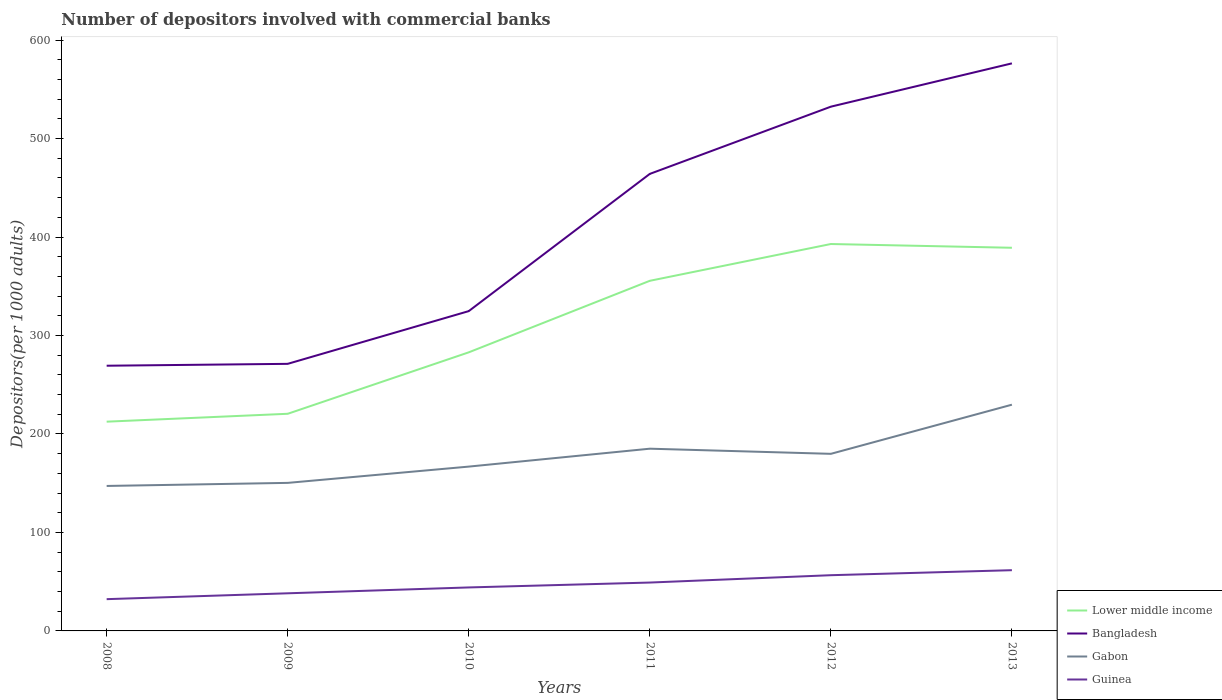Does the line corresponding to Gabon intersect with the line corresponding to Lower middle income?
Keep it short and to the point. No. Across all years, what is the maximum number of depositors involved with commercial banks in Gabon?
Your answer should be compact. 147.22. What is the total number of depositors involved with commercial banks in Gabon in the graph?
Your response must be concise. -79.41. What is the difference between the highest and the second highest number of depositors involved with commercial banks in Gabon?
Your answer should be very brief. 82.52. How many lines are there?
Ensure brevity in your answer.  4. What is the difference between two consecutive major ticks on the Y-axis?
Your answer should be compact. 100. Are the values on the major ticks of Y-axis written in scientific E-notation?
Offer a terse response. No. Does the graph contain any zero values?
Your answer should be compact. No. Does the graph contain grids?
Provide a short and direct response. No. Where does the legend appear in the graph?
Ensure brevity in your answer.  Bottom right. How are the legend labels stacked?
Offer a terse response. Vertical. What is the title of the graph?
Your response must be concise. Number of depositors involved with commercial banks. What is the label or title of the X-axis?
Your answer should be compact. Years. What is the label or title of the Y-axis?
Offer a very short reply. Depositors(per 1000 adults). What is the Depositors(per 1000 adults) in Lower middle income in 2008?
Offer a very short reply. 212.5. What is the Depositors(per 1000 adults) of Bangladesh in 2008?
Provide a short and direct response. 269.32. What is the Depositors(per 1000 adults) in Gabon in 2008?
Give a very brief answer. 147.22. What is the Depositors(per 1000 adults) of Guinea in 2008?
Provide a short and direct response. 32.26. What is the Depositors(per 1000 adults) in Lower middle income in 2009?
Give a very brief answer. 220.51. What is the Depositors(per 1000 adults) in Bangladesh in 2009?
Your answer should be very brief. 271.23. What is the Depositors(per 1000 adults) in Gabon in 2009?
Provide a succinct answer. 150.34. What is the Depositors(per 1000 adults) in Guinea in 2009?
Your response must be concise. 38.21. What is the Depositors(per 1000 adults) in Lower middle income in 2010?
Provide a short and direct response. 282.91. What is the Depositors(per 1000 adults) in Bangladesh in 2010?
Offer a terse response. 324.78. What is the Depositors(per 1000 adults) of Gabon in 2010?
Provide a succinct answer. 166.87. What is the Depositors(per 1000 adults) of Guinea in 2010?
Give a very brief answer. 44.16. What is the Depositors(per 1000 adults) of Lower middle income in 2011?
Keep it short and to the point. 355.56. What is the Depositors(per 1000 adults) of Bangladesh in 2011?
Offer a very short reply. 464.13. What is the Depositors(per 1000 adults) of Gabon in 2011?
Ensure brevity in your answer.  185.06. What is the Depositors(per 1000 adults) of Guinea in 2011?
Your response must be concise. 49.12. What is the Depositors(per 1000 adults) of Lower middle income in 2012?
Provide a succinct answer. 392.92. What is the Depositors(per 1000 adults) of Bangladesh in 2012?
Offer a very short reply. 532.4. What is the Depositors(per 1000 adults) in Gabon in 2012?
Ensure brevity in your answer.  179.84. What is the Depositors(per 1000 adults) in Guinea in 2012?
Give a very brief answer. 56.59. What is the Depositors(per 1000 adults) in Lower middle income in 2013?
Offer a terse response. 389.11. What is the Depositors(per 1000 adults) of Bangladesh in 2013?
Your answer should be compact. 576.37. What is the Depositors(per 1000 adults) in Gabon in 2013?
Your answer should be very brief. 229.74. What is the Depositors(per 1000 adults) of Guinea in 2013?
Keep it short and to the point. 61.68. Across all years, what is the maximum Depositors(per 1000 adults) in Lower middle income?
Offer a terse response. 392.92. Across all years, what is the maximum Depositors(per 1000 adults) in Bangladesh?
Your answer should be very brief. 576.37. Across all years, what is the maximum Depositors(per 1000 adults) of Gabon?
Provide a short and direct response. 229.74. Across all years, what is the maximum Depositors(per 1000 adults) of Guinea?
Your answer should be compact. 61.68. Across all years, what is the minimum Depositors(per 1000 adults) in Lower middle income?
Your answer should be very brief. 212.5. Across all years, what is the minimum Depositors(per 1000 adults) of Bangladesh?
Keep it short and to the point. 269.32. Across all years, what is the minimum Depositors(per 1000 adults) in Gabon?
Your answer should be very brief. 147.22. Across all years, what is the minimum Depositors(per 1000 adults) in Guinea?
Offer a terse response. 32.26. What is the total Depositors(per 1000 adults) in Lower middle income in the graph?
Ensure brevity in your answer.  1853.51. What is the total Depositors(per 1000 adults) of Bangladesh in the graph?
Your answer should be compact. 2438.22. What is the total Depositors(per 1000 adults) of Gabon in the graph?
Your response must be concise. 1059.08. What is the total Depositors(per 1000 adults) in Guinea in the graph?
Keep it short and to the point. 282.02. What is the difference between the Depositors(per 1000 adults) in Lower middle income in 2008 and that in 2009?
Keep it short and to the point. -8.01. What is the difference between the Depositors(per 1000 adults) in Bangladesh in 2008 and that in 2009?
Make the answer very short. -1.91. What is the difference between the Depositors(per 1000 adults) in Gabon in 2008 and that in 2009?
Ensure brevity in your answer.  -3.11. What is the difference between the Depositors(per 1000 adults) of Guinea in 2008 and that in 2009?
Your answer should be compact. -5.95. What is the difference between the Depositors(per 1000 adults) in Lower middle income in 2008 and that in 2010?
Provide a succinct answer. -70.41. What is the difference between the Depositors(per 1000 adults) of Bangladesh in 2008 and that in 2010?
Make the answer very short. -55.46. What is the difference between the Depositors(per 1000 adults) in Gabon in 2008 and that in 2010?
Ensure brevity in your answer.  -19.65. What is the difference between the Depositors(per 1000 adults) of Guinea in 2008 and that in 2010?
Offer a very short reply. -11.9. What is the difference between the Depositors(per 1000 adults) in Lower middle income in 2008 and that in 2011?
Make the answer very short. -143.06. What is the difference between the Depositors(per 1000 adults) in Bangladesh in 2008 and that in 2011?
Your answer should be very brief. -194.81. What is the difference between the Depositors(per 1000 adults) in Gabon in 2008 and that in 2011?
Your answer should be very brief. -37.83. What is the difference between the Depositors(per 1000 adults) in Guinea in 2008 and that in 2011?
Keep it short and to the point. -16.87. What is the difference between the Depositors(per 1000 adults) in Lower middle income in 2008 and that in 2012?
Offer a very short reply. -180.42. What is the difference between the Depositors(per 1000 adults) of Bangladesh in 2008 and that in 2012?
Ensure brevity in your answer.  -263.08. What is the difference between the Depositors(per 1000 adults) in Gabon in 2008 and that in 2012?
Make the answer very short. -32.62. What is the difference between the Depositors(per 1000 adults) of Guinea in 2008 and that in 2012?
Ensure brevity in your answer.  -24.33. What is the difference between the Depositors(per 1000 adults) in Lower middle income in 2008 and that in 2013?
Offer a terse response. -176.6. What is the difference between the Depositors(per 1000 adults) in Bangladesh in 2008 and that in 2013?
Your answer should be very brief. -307.05. What is the difference between the Depositors(per 1000 adults) of Gabon in 2008 and that in 2013?
Keep it short and to the point. -82.52. What is the difference between the Depositors(per 1000 adults) in Guinea in 2008 and that in 2013?
Provide a short and direct response. -29.43. What is the difference between the Depositors(per 1000 adults) in Lower middle income in 2009 and that in 2010?
Ensure brevity in your answer.  -62.4. What is the difference between the Depositors(per 1000 adults) in Bangladesh in 2009 and that in 2010?
Provide a short and direct response. -53.55. What is the difference between the Depositors(per 1000 adults) in Gabon in 2009 and that in 2010?
Your answer should be very brief. -16.54. What is the difference between the Depositors(per 1000 adults) in Guinea in 2009 and that in 2010?
Provide a succinct answer. -5.95. What is the difference between the Depositors(per 1000 adults) in Lower middle income in 2009 and that in 2011?
Make the answer very short. -135.05. What is the difference between the Depositors(per 1000 adults) in Bangladesh in 2009 and that in 2011?
Provide a succinct answer. -192.9. What is the difference between the Depositors(per 1000 adults) in Gabon in 2009 and that in 2011?
Your answer should be compact. -34.72. What is the difference between the Depositors(per 1000 adults) in Guinea in 2009 and that in 2011?
Offer a terse response. -10.92. What is the difference between the Depositors(per 1000 adults) in Lower middle income in 2009 and that in 2012?
Ensure brevity in your answer.  -172.41. What is the difference between the Depositors(per 1000 adults) in Bangladesh in 2009 and that in 2012?
Your answer should be compact. -261.17. What is the difference between the Depositors(per 1000 adults) of Gabon in 2009 and that in 2012?
Your answer should be compact. -29.5. What is the difference between the Depositors(per 1000 adults) of Guinea in 2009 and that in 2012?
Provide a short and direct response. -18.38. What is the difference between the Depositors(per 1000 adults) in Lower middle income in 2009 and that in 2013?
Your response must be concise. -168.6. What is the difference between the Depositors(per 1000 adults) of Bangladesh in 2009 and that in 2013?
Offer a terse response. -305.15. What is the difference between the Depositors(per 1000 adults) in Gabon in 2009 and that in 2013?
Make the answer very short. -79.41. What is the difference between the Depositors(per 1000 adults) in Guinea in 2009 and that in 2013?
Offer a terse response. -23.47. What is the difference between the Depositors(per 1000 adults) in Lower middle income in 2010 and that in 2011?
Give a very brief answer. -72.64. What is the difference between the Depositors(per 1000 adults) of Bangladesh in 2010 and that in 2011?
Your answer should be very brief. -139.35. What is the difference between the Depositors(per 1000 adults) in Gabon in 2010 and that in 2011?
Ensure brevity in your answer.  -18.18. What is the difference between the Depositors(per 1000 adults) of Guinea in 2010 and that in 2011?
Keep it short and to the point. -4.97. What is the difference between the Depositors(per 1000 adults) of Lower middle income in 2010 and that in 2012?
Ensure brevity in your answer.  -110.01. What is the difference between the Depositors(per 1000 adults) in Bangladesh in 2010 and that in 2012?
Offer a terse response. -207.62. What is the difference between the Depositors(per 1000 adults) of Gabon in 2010 and that in 2012?
Offer a terse response. -12.97. What is the difference between the Depositors(per 1000 adults) in Guinea in 2010 and that in 2012?
Make the answer very short. -12.44. What is the difference between the Depositors(per 1000 adults) of Lower middle income in 2010 and that in 2013?
Give a very brief answer. -106.19. What is the difference between the Depositors(per 1000 adults) in Bangladesh in 2010 and that in 2013?
Keep it short and to the point. -251.6. What is the difference between the Depositors(per 1000 adults) of Gabon in 2010 and that in 2013?
Keep it short and to the point. -62.87. What is the difference between the Depositors(per 1000 adults) in Guinea in 2010 and that in 2013?
Provide a succinct answer. -17.53. What is the difference between the Depositors(per 1000 adults) of Lower middle income in 2011 and that in 2012?
Offer a very short reply. -37.36. What is the difference between the Depositors(per 1000 adults) of Bangladesh in 2011 and that in 2012?
Make the answer very short. -68.27. What is the difference between the Depositors(per 1000 adults) in Gabon in 2011 and that in 2012?
Provide a short and direct response. 5.22. What is the difference between the Depositors(per 1000 adults) of Guinea in 2011 and that in 2012?
Give a very brief answer. -7.47. What is the difference between the Depositors(per 1000 adults) in Lower middle income in 2011 and that in 2013?
Keep it short and to the point. -33.55. What is the difference between the Depositors(per 1000 adults) of Bangladesh in 2011 and that in 2013?
Your answer should be very brief. -112.24. What is the difference between the Depositors(per 1000 adults) in Gabon in 2011 and that in 2013?
Make the answer very short. -44.69. What is the difference between the Depositors(per 1000 adults) of Guinea in 2011 and that in 2013?
Ensure brevity in your answer.  -12.56. What is the difference between the Depositors(per 1000 adults) in Lower middle income in 2012 and that in 2013?
Provide a short and direct response. 3.82. What is the difference between the Depositors(per 1000 adults) of Bangladesh in 2012 and that in 2013?
Ensure brevity in your answer.  -43.98. What is the difference between the Depositors(per 1000 adults) in Gabon in 2012 and that in 2013?
Make the answer very short. -49.9. What is the difference between the Depositors(per 1000 adults) of Guinea in 2012 and that in 2013?
Offer a terse response. -5.09. What is the difference between the Depositors(per 1000 adults) in Lower middle income in 2008 and the Depositors(per 1000 adults) in Bangladesh in 2009?
Ensure brevity in your answer.  -58.73. What is the difference between the Depositors(per 1000 adults) in Lower middle income in 2008 and the Depositors(per 1000 adults) in Gabon in 2009?
Provide a short and direct response. 62.16. What is the difference between the Depositors(per 1000 adults) of Lower middle income in 2008 and the Depositors(per 1000 adults) of Guinea in 2009?
Provide a succinct answer. 174.29. What is the difference between the Depositors(per 1000 adults) of Bangladesh in 2008 and the Depositors(per 1000 adults) of Gabon in 2009?
Make the answer very short. 118.98. What is the difference between the Depositors(per 1000 adults) in Bangladesh in 2008 and the Depositors(per 1000 adults) in Guinea in 2009?
Provide a short and direct response. 231.11. What is the difference between the Depositors(per 1000 adults) in Gabon in 2008 and the Depositors(per 1000 adults) in Guinea in 2009?
Your answer should be very brief. 109.02. What is the difference between the Depositors(per 1000 adults) in Lower middle income in 2008 and the Depositors(per 1000 adults) in Bangladesh in 2010?
Keep it short and to the point. -112.28. What is the difference between the Depositors(per 1000 adults) of Lower middle income in 2008 and the Depositors(per 1000 adults) of Gabon in 2010?
Provide a short and direct response. 45.63. What is the difference between the Depositors(per 1000 adults) in Lower middle income in 2008 and the Depositors(per 1000 adults) in Guinea in 2010?
Your answer should be very brief. 168.35. What is the difference between the Depositors(per 1000 adults) of Bangladesh in 2008 and the Depositors(per 1000 adults) of Gabon in 2010?
Ensure brevity in your answer.  102.45. What is the difference between the Depositors(per 1000 adults) in Bangladesh in 2008 and the Depositors(per 1000 adults) in Guinea in 2010?
Provide a succinct answer. 225.16. What is the difference between the Depositors(per 1000 adults) in Gabon in 2008 and the Depositors(per 1000 adults) in Guinea in 2010?
Provide a succinct answer. 103.07. What is the difference between the Depositors(per 1000 adults) in Lower middle income in 2008 and the Depositors(per 1000 adults) in Bangladesh in 2011?
Give a very brief answer. -251.63. What is the difference between the Depositors(per 1000 adults) in Lower middle income in 2008 and the Depositors(per 1000 adults) in Gabon in 2011?
Your response must be concise. 27.44. What is the difference between the Depositors(per 1000 adults) in Lower middle income in 2008 and the Depositors(per 1000 adults) in Guinea in 2011?
Offer a terse response. 163.38. What is the difference between the Depositors(per 1000 adults) of Bangladesh in 2008 and the Depositors(per 1000 adults) of Gabon in 2011?
Keep it short and to the point. 84.26. What is the difference between the Depositors(per 1000 adults) of Bangladesh in 2008 and the Depositors(per 1000 adults) of Guinea in 2011?
Keep it short and to the point. 220.2. What is the difference between the Depositors(per 1000 adults) of Gabon in 2008 and the Depositors(per 1000 adults) of Guinea in 2011?
Offer a terse response. 98.1. What is the difference between the Depositors(per 1000 adults) of Lower middle income in 2008 and the Depositors(per 1000 adults) of Bangladesh in 2012?
Ensure brevity in your answer.  -319.9. What is the difference between the Depositors(per 1000 adults) of Lower middle income in 2008 and the Depositors(per 1000 adults) of Gabon in 2012?
Ensure brevity in your answer.  32.66. What is the difference between the Depositors(per 1000 adults) in Lower middle income in 2008 and the Depositors(per 1000 adults) in Guinea in 2012?
Your answer should be compact. 155.91. What is the difference between the Depositors(per 1000 adults) of Bangladesh in 2008 and the Depositors(per 1000 adults) of Gabon in 2012?
Offer a very short reply. 89.48. What is the difference between the Depositors(per 1000 adults) of Bangladesh in 2008 and the Depositors(per 1000 adults) of Guinea in 2012?
Make the answer very short. 212.73. What is the difference between the Depositors(per 1000 adults) of Gabon in 2008 and the Depositors(per 1000 adults) of Guinea in 2012?
Your response must be concise. 90.63. What is the difference between the Depositors(per 1000 adults) of Lower middle income in 2008 and the Depositors(per 1000 adults) of Bangladesh in 2013?
Offer a terse response. -363.87. What is the difference between the Depositors(per 1000 adults) in Lower middle income in 2008 and the Depositors(per 1000 adults) in Gabon in 2013?
Your answer should be compact. -17.24. What is the difference between the Depositors(per 1000 adults) of Lower middle income in 2008 and the Depositors(per 1000 adults) of Guinea in 2013?
Provide a short and direct response. 150.82. What is the difference between the Depositors(per 1000 adults) of Bangladesh in 2008 and the Depositors(per 1000 adults) of Gabon in 2013?
Give a very brief answer. 39.58. What is the difference between the Depositors(per 1000 adults) of Bangladesh in 2008 and the Depositors(per 1000 adults) of Guinea in 2013?
Ensure brevity in your answer.  207.64. What is the difference between the Depositors(per 1000 adults) of Gabon in 2008 and the Depositors(per 1000 adults) of Guinea in 2013?
Ensure brevity in your answer.  85.54. What is the difference between the Depositors(per 1000 adults) in Lower middle income in 2009 and the Depositors(per 1000 adults) in Bangladesh in 2010?
Offer a terse response. -104.27. What is the difference between the Depositors(per 1000 adults) of Lower middle income in 2009 and the Depositors(per 1000 adults) of Gabon in 2010?
Keep it short and to the point. 53.64. What is the difference between the Depositors(per 1000 adults) in Lower middle income in 2009 and the Depositors(per 1000 adults) in Guinea in 2010?
Provide a short and direct response. 176.35. What is the difference between the Depositors(per 1000 adults) of Bangladesh in 2009 and the Depositors(per 1000 adults) of Gabon in 2010?
Your answer should be very brief. 104.35. What is the difference between the Depositors(per 1000 adults) of Bangladesh in 2009 and the Depositors(per 1000 adults) of Guinea in 2010?
Keep it short and to the point. 227.07. What is the difference between the Depositors(per 1000 adults) of Gabon in 2009 and the Depositors(per 1000 adults) of Guinea in 2010?
Give a very brief answer. 106.18. What is the difference between the Depositors(per 1000 adults) in Lower middle income in 2009 and the Depositors(per 1000 adults) in Bangladesh in 2011?
Ensure brevity in your answer.  -243.62. What is the difference between the Depositors(per 1000 adults) in Lower middle income in 2009 and the Depositors(per 1000 adults) in Gabon in 2011?
Provide a succinct answer. 35.45. What is the difference between the Depositors(per 1000 adults) of Lower middle income in 2009 and the Depositors(per 1000 adults) of Guinea in 2011?
Ensure brevity in your answer.  171.39. What is the difference between the Depositors(per 1000 adults) in Bangladesh in 2009 and the Depositors(per 1000 adults) in Gabon in 2011?
Keep it short and to the point. 86.17. What is the difference between the Depositors(per 1000 adults) of Bangladesh in 2009 and the Depositors(per 1000 adults) of Guinea in 2011?
Your response must be concise. 222.1. What is the difference between the Depositors(per 1000 adults) of Gabon in 2009 and the Depositors(per 1000 adults) of Guinea in 2011?
Provide a succinct answer. 101.21. What is the difference between the Depositors(per 1000 adults) in Lower middle income in 2009 and the Depositors(per 1000 adults) in Bangladesh in 2012?
Your answer should be compact. -311.89. What is the difference between the Depositors(per 1000 adults) in Lower middle income in 2009 and the Depositors(per 1000 adults) in Gabon in 2012?
Offer a very short reply. 40.67. What is the difference between the Depositors(per 1000 adults) of Lower middle income in 2009 and the Depositors(per 1000 adults) of Guinea in 2012?
Ensure brevity in your answer.  163.92. What is the difference between the Depositors(per 1000 adults) in Bangladesh in 2009 and the Depositors(per 1000 adults) in Gabon in 2012?
Provide a short and direct response. 91.39. What is the difference between the Depositors(per 1000 adults) of Bangladesh in 2009 and the Depositors(per 1000 adults) of Guinea in 2012?
Provide a succinct answer. 214.64. What is the difference between the Depositors(per 1000 adults) of Gabon in 2009 and the Depositors(per 1000 adults) of Guinea in 2012?
Offer a terse response. 93.75. What is the difference between the Depositors(per 1000 adults) of Lower middle income in 2009 and the Depositors(per 1000 adults) of Bangladesh in 2013?
Your answer should be compact. -355.86. What is the difference between the Depositors(per 1000 adults) in Lower middle income in 2009 and the Depositors(per 1000 adults) in Gabon in 2013?
Ensure brevity in your answer.  -9.23. What is the difference between the Depositors(per 1000 adults) in Lower middle income in 2009 and the Depositors(per 1000 adults) in Guinea in 2013?
Make the answer very short. 158.83. What is the difference between the Depositors(per 1000 adults) in Bangladesh in 2009 and the Depositors(per 1000 adults) in Gabon in 2013?
Offer a very short reply. 41.48. What is the difference between the Depositors(per 1000 adults) of Bangladesh in 2009 and the Depositors(per 1000 adults) of Guinea in 2013?
Make the answer very short. 209.55. What is the difference between the Depositors(per 1000 adults) of Gabon in 2009 and the Depositors(per 1000 adults) of Guinea in 2013?
Offer a very short reply. 88.66. What is the difference between the Depositors(per 1000 adults) of Lower middle income in 2010 and the Depositors(per 1000 adults) of Bangladesh in 2011?
Your response must be concise. -181.22. What is the difference between the Depositors(per 1000 adults) of Lower middle income in 2010 and the Depositors(per 1000 adults) of Gabon in 2011?
Provide a succinct answer. 97.85. What is the difference between the Depositors(per 1000 adults) in Lower middle income in 2010 and the Depositors(per 1000 adults) in Guinea in 2011?
Give a very brief answer. 233.79. What is the difference between the Depositors(per 1000 adults) of Bangladesh in 2010 and the Depositors(per 1000 adults) of Gabon in 2011?
Offer a terse response. 139.72. What is the difference between the Depositors(per 1000 adults) of Bangladesh in 2010 and the Depositors(per 1000 adults) of Guinea in 2011?
Keep it short and to the point. 275.65. What is the difference between the Depositors(per 1000 adults) in Gabon in 2010 and the Depositors(per 1000 adults) in Guinea in 2011?
Provide a short and direct response. 117.75. What is the difference between the Depositors(per 1000 adults) of Lower middle income in 2010 and the Depositors(per 1000 adults) of Bangladesh in 2012?
Provide a short and direct response. -249.49. What is the difference between the Depositors(per 1000 adults) of Lower middle income in 2010 and the Depositors(per 1000 adults) of Gabon in 2012?
Your answer should be very brief. 103.07. What is the difference between the Depositors(per 1000 adults) of Lower middle income in 2010 and the Depositors(per 1000 adults) of Guinea in 2012?
Your response must be concise. 226.32. What is the difference between the Depositors(per 1000 adults) in Bangladesh in 2010 and the Depositors(per 1000 adults) in Gabon in 2012?
Your response must be concise. 144.94. What is the difference between the Depositors(per 1000 adults) in Bangladesh in 2010 and the Depositors(per 1000 adults) in Guinea in 2012?
Ensure brevity in your answer.  268.19. What is the difference between the Depositors(per 1000 adults) of Gabon in 2010 and the Depositors(per 1000 adults) of Guinea in 2012?
Provide a succinct answer. 110.28. What is the difference between the Depositors(per 1000 adults) of Lower middle income in 2010 and the Depositors(per 1000 adults) of Bangladesh in 2013?
Offer a very short reply. -293.46. What is the difference between the Depositors(per 1000 adults) in Lower middle income in 2010 and the Depositors(per 1000 adults) in Gabon in 2013?
Your answer should be compact. 53.17. What is the difference between the Depositors(per 1000 adults) in Lower middle income in 2010 and the Depositors(per 1000 adults) in Guinea in 2013?
Your answer should be very brief. 221.23. What is the difference between the Depositors(per 1000 adults) of Bangladesh in 2010 and the Depositors(per 1000 adults) of Gabon in 2013?
Make the answer very short. 95.03. What is the difference between the Depositors(per 1000 adults) of Bangladesh in 2010 and the Depositors(per 1000 adults) of Guinea in 2013?
Offer a terse response. 263.09. What is the difference between the Depositors(per 1000 adults) of Gabon in 2010 and the Depositors(per 1000 adults) of Guinea in 2013?
Offer a terse response. 105.19. What is the difference between the Depositors(per 1000 adults) of Lower middle income in 2011 and the Depositors(per 1000 adults) of Bangladesh in 2012?
Offer a very short reply. -176.84. What is the difference between the Depositors(per 1000 adults) of Lower middle income in 2011 and the Depositors(per 1000 adults) of Gabon in 2012?
Give a very brief answer. 175.72. What is the difference between the Depositors(per 1000 adults) of Lower middle income in 2011 and the Depositors(per 1000 adults) of Guinea in 2012?
Offer a terse response. 298.97. What is the difference between the Depositors(per 1000 adults) of Bangladesh in 2011 and the Depositors(per 1000 adults) of Gabon in 2012?
Provide a succinct answer. 284.29. What is the difference between the Depositors(per 1000 adults) in Bangladesh in 2011 and the Depositors(per 1000 adults) in Guinea in 2012?
Make the answer very short. 407.54. What is the difference between the Depositors(per 1000 adults) of Gabon in 2011 and the Depositors(per 1000 adults) of Guinea in 2012?
Give a very brief answer. 128.47. What is the difference between the Depositors(per 1000 adults) of Lower middle income in 2011 and the Depositors(per 1000 adults) of Bangladesh in 2013?
Your response must be concise. -220.82. What is the difference between the Depositors(per 1000 adults) of Lower middle income in 2011 and the Depositors(per 1000 adults) of Gabon in 2013?
Offer a terse response. 125.81. What is the difference between the Depositors(per 1000 adults) of Lower middle income in 2011 and the Depositors(per 1000 adults) of Guinea in 2013?
Offer a very short reply. 293.87. What is the difference between the Depositors(per 1000 adults) in Bangladesh in 2011 and the Depositors(per 1000 adults) in Gabon in 2013?
Give a very brief answer. 234.39. What is the difference between the Depositors(per 1000 adults) in Bangladesh in 2011 and the Depositors(per 1000 adults) in Guinea in 2013?
Ensure brevity in your answer.  402.45. What is the difference between the Depositors(per 1000 adults) in Gabon in 2011 and the Depositors(per 1000 adults) in Guinea in 2013?
Offer a terse response. 123.37. What is the difference between the Depositors(per 1000 adults) of Lower middle income in 2012 and the Depositors(per 1000 adults) of Bangladesh in 2013?
Give a very brief answer. -183.45. What is the difference between the Depositors(per 1000 adults) in Lower middle income in 2012 and the Depositors(per 1000 adults) in Gabon in 2013?
Provide a succinct answer. 163.18. What is the difference between the Depositors(per 1000 adults) in Lower middle income in 2012 and the Depositors(per 1000 adults) in Guinea in 2013?
Your response must be concise. 331.24. What is the difference between the Depositors(per 1000 adults) in Bangladesh in 2012 and the Depositors(per 1000 adults) in Gabon in 2013?
Offer a terse response. 302.65. What is the difference between the Depositors(per 1000 adults) of Bangladesh in 2012 and the Depositors(per 1000 adults) of Guinea in 2013?
Offer a terse response. 470.72. What is the difference between the Depositors(per 1000 adults) in Gabon in 2012 and the Depositors(per 1000 adults) in Guinea in 2013?
Provide a succinct answer. 118.16. What is the average Depositors(per 1000 adults) of Lower middle income per year?
Give a very brief answer. 308.92. What is the average Depositors(per 1000 adults) of Bangladesh per year?
Ensure brevity in your answer.  406.37. What is the average Depositors(per 1000 adults) in Gabon per year?
Provide a succinct answer. 176.51. What is the average Depositors(per 1000 adults) in Guinea per year?
Keep it short and to the point. 47. In the year 2008, what is the difference between the Depositors(per 1000 adults) of Lower middle income and Depositors(per 1000 adults) of Bangladesh?
Offer a very short reply. -56.82. In the year 2008, what is the difference between the Depositors(per 1000 adults) in Lower middle income and Depositors(per 1000 adults) in Gabon?
Provide a succinct answer. 65.28. In the year 2008, what is the difference between the Depositors(per 1000 adults) in Lower middle income and Depositors(per 1000 adults) in Guinea?
Provide a short and direct response. 180.24. In the year 2008, what is the difference between the Depositors(per 1000 adults) in Bangladesh and Depositors(per 1000 adults) in Gabon?
Ensure brevity in your answer.  122.1. In the year 2008, what is the difference between the Depositors(per 1000 adults) in Bangladesh and Depositors(per 1000 adults) in Guinea?
Provide a short and direct response. 237.06. In the year 2008, what is the difference between the Depositors(per 1000 adults) of Gabon and Depositors(per 1000 adults) of Guinea?
Your response must be concise. 114.97. In the year 2009, what is the difference between the Depositors(per 1000 adults) of Lower middle income and Depositors(per 1000 adults) of Bangladesh?
Provide a short and direct response. -50.72. In the year 2009, what is the difference between the Depositors(per 1000 adults) of Lower middle income and Depositors(per 1000 adults) of Gabon?
Your response must be concise. 70.17. In the year 2009, what is the difference between the Depositors(per 1000 adults) of Lower middle income and Depositors(per 1000 adults) of Guinea?
Offer a very short reply. 182.3. In the year 2009, what is the difference between the Depositors(per 1000 adults) of Bangladesh and Depositors(per 1000 adults) of Gabon?
Offer a very short reply. 120.89. In the year 2009, what is the difference between the Depositors(per 1000 adults) in Bangladesh and Depositors(per 1000 adults) in Guinea?
Your response must be concise. 233.02. In the year 2009, what is the difference between the Depositors(per 1000 adults) in Gabon and Depositors(per 1000 adults) in Guinea?
Ensure brevity in your answer.  112.13. In the year 2010, what is the difference between the Depositors(per 1000 adults) in Lower middle income and Depositors(per 1000 adults) in Bangladesh?
Your response must be concise. -41.86. In the year 2010, what is the difference between the Depositors(per 1000 adults) in Lower middle income and Depositors(per 1000 adults) in Gabon?
Offer a terse response. 116.04. In the year 2010, what is the difference between the Depositors(per 1000 adults) in Lower middle income and Depositors(per 1000 adults) in Guinea?
Your answer should be compact. 238.76. In the year 2010, what is the difference between the Depositors(per 1000 adults) of Bangladesh and Depositors(per 1000 adults) of Gabon?
Offer a very short reply. 157.9. In the year 2010, what is the difference between the Depositors(per 1000 adults) of Bangladesh and Depositors(per 1000 adults) of Guinea?
Offer a very short reply. 280.62. In the year 2010, what is the difference between the Depositors(per 1000 adults) in Gabon and Depositors(per 1000 adults) in Guinea?
Give a very brief answer. 122.72. In the year 2011, what is the difference between the Depositors(per 1000 adults) in Lower middle income and Depositors(per 1000 adults) in Bangladesh?
Provide a short and direct response. -108.57. In the year 2011, what is the difference between the Depositors(per 1000 adults) in Lower middle income and Depositors(per 1000 adults) in Gabon?
Make the answer very short. 170.5. In the year 2011, what is the difference between the Depositors(per 1000 adults) of Lower middle income and Depositors(per 1000 adults) of Guinea?
Offer a very short reply. 306.43. In the year 2011, what is the difference between the Depositors(per 1000 adults) in Bangladesh and Depositors(per 1000 adults) in Gabon?
Ensure brevity in your answer.  279.07. In the year 2011, what is the difference between the Depositors(per 1000 adults) in Bangladesh and Depositors(per 1000 adults) in Guinea?
Offer a terse response. 415.01. In the year 2011, what is the difference between the Depositors(per 1000 adults) in Gabon and Depositors(per 1000 adults) in Guinea?
Ensure brevity in your answer.  135.93. In the year 2012, what is the difference between the Depositors(per 1000 adults) in Lower middle income and Depositors(per 1000 adults) in Bangladesh?
Your answer should be very brief. -139.48. In the year 2012, what is the difference between the Depositors(per 1000 adults) of Lower middle income and Depositors(per 1000 adults) of Gabon?
Provide a short and direct response. 213.08. In the year 2012, what is the difference between the Depositors(per 1000 adults) in Lower middle income and Depositors(per 1000 adults) in Guinea?
Keep it short and to the point. 336.33. In the year 2012, what is the difference between the Depositors(per 1000 adults) in Bangladesh and Depositors(per 1000 adults) in Gabon?
Ensure brevity in your answer.  352.56. In the year 2012, what is the difference between the Depositors(per 1000 adults) in Bangladesh and Depositors(per 1000 adults) in Guinea?
Your answer should be very brief. 475.81. In the year 2012, what is the difference between the Depositors(per 1000 adults) in Gabon and Depositors(per 1000 adults) in Guinea?
Your response must be concise. 123.25. In the year 2013, what is the difference between the Depositors(per 1000 adults) of Lower middle income and Depositors(per 1000 adults) of Bangladesh?
Your answer should be compact. -187.27. In the year 2013, what is the difference between the Depositors(per 1000 adults) of Lower middle income and Depositors(per 1000 adults) of Gabon?
Ensure brevity in your answer.  159.36. In the year 2013, what is the difference between the Depositors(per 1000 adults) of Lower middle income and Depositors(per 1000 adults) of Guinea?
Your answer should be very brief. 327.42. In the year 2013, what is the difference between the Depositors(per 1000 adults) in Bangladesh and Depositors(per 1000 adults) in Gabon?
Provide a succinct answer. 346.63. In the year 2013, what is the difference between the Depositors(per 1000 adults) of Bangladesh and Depositors(per 1000 adults) of Guinea?
Your answer should be compact. 514.69. In the year 2013, what is the difference between the Depositors(per 1000 adults) in Gabon and Depositors(per 1000 adults) in Guinea?
Your answer should be compact. 168.06. What is the ratio of the Depositors(per 1000 adults) in Lower middle income in 2008 to that in 2009?
Ensure brevity in your answer.  0.96. What is the ratio of the Depositors(per 1000 adults) in Bangladesh in 2008 to that in 2009?
Offer a terse response. 0.99. What is the ratio of the Depositors(per 1000 adults) in Gabon in 2008 to that in 2009?
Your response must be concise. 0.98. What is the ratio of the Depositors(per 1000 adults) in Guinea in 2008 to that in 2009?
Offer a very short reply. 0.84. What is the ratio of the Depositors(per 1000 adults) of Lower middle income in 2008 to that in 2010?
Ensure brevity in your answer.  0.75. What is the ratio of the Depositors(per 1000 adults) of Bangladesh in 2008 to that in 2010?
Offer a terse response. 0.83. What is the ratio of the Depositors(per 1000 adults) of Gabon in 2008 to that in 2010?
Offer a very short reply. 0.88. What is the ratio of the Depositors(per 1000 adults) of Guinea in 2008 to that in 2010?
Ensure brevity in your answer.  0.73. What is the ratio of the Depositors(per 1000 adults) of Lower middle income in 2008 to that in 2011?
Your answer should be compact. 0.6. What is the ratio of the Depositors(per 1000 adults) of Bangladesh in 2008 to that in 2011?
Ensure brevity in your answer.  0.58. What is the ratio of the Depositors(per 1000 adults) of Gabon in 2008 to that in 2011?
Make the answer very short. 0.8. What is the ratio of the Depositors(per 1000 adults) of Guinea in 2008 to that in 2011?
Your response must be concise. 0.66. What is the ratio of the Depositors(per 1000 adults) of Lower middle income in 2008 to that in 2012?
Offer a very short reply. 0.54. What is the ratio of the Depositors(per 1000 adults) in Bangladesh in 2008 to that in 2012?
Your answer should be compact. 0.51. What is the ratio of the Depositors(per 1000 adults) of Gabon in 2008 to that in 2012?
Ensure brevity in your answer.  0.82. What is the ratio of the Depositors(per 1000 adults) in Guinea in 2008 to that in 2012?
Ensure brevity in your answer.  0.57. What is the ratio of the Depositors(per 1000 adults) of Lower middle income in 2008 to that in 2013?
Provide a succinct answer. 0.55. What is the ratio of the Depositors(per 1000 adults) in Bangladesh in 2008 to that in 2013?
Ensure brevity in your answer.  0.47. What is the ratio of the Depositors(per 1000 adults) in Gabon in 2008 to that in 2013?
Provide a succinct answer. 0.64. What is the ratio of the Depositors(per 1000 adults) of Guinea in 2008 to that in 2013?
Your response must be concise. 0.52. What is the ratio of the Depositors(per 1000 adults) of Lower middle income in 2009 to that in 2010?
Your response must be concise. 0.78. What is the ratio of the Depositors(per 1000 adults) in Bangladesh in 2009 to that in 2010?
Provide a succinct answer. 0.84. What is the ratio of the Depositors(per 1000 adults) in Gabon in 2009 to that in 2010?
Provide a short and direct response. 0.9. What is the ratio of the Depositors(per 1000 adults) in Guinea in 2009 to that in 2010?
Make the answer very short. 0.87. What is the ratio of the Depositors(per 1000 adults) in Lower middle income in 2009 to that in 2011?
Provide a succinct answer. 0.62. What is the ratio of the Depositors(per 1000 adults) of Bangladesh in 2009 to that in 2011?
Ensure brevity in your answer.  0.58. What is the ratio of the Depositors(per 1000 adults) of Gabon in 2009 to that in 2011?
Your response must be concise. 0.81. What is the ratio of the Depositors(per 1000 adults) of Lower middle income in 2009 to that in 2012?
Your answer should be very brief. 0.56. What is the ratio of the Depositors(per 1000 adults) of Bangladesh in 2009 to that in 2012?
Ensure brevity in your answer.  0.51. What is the ratio of the Depositors(per 1000 adults) in Gabon in 2009 to that in 2012?
Keep it short and to the point. 0.84. What is the ratio of the Depositors(per 1000 adults) of Guinea in 2009 to that in 2012?
Ensure brevity in your answer.  0.68. What is the ratio of the Depositors(per 1000 adults) of Lower middle income in 2009 to that in 2013?
Your response must be concise. 0.57. What is the ratio of the Depositors(per 1000 adults) of Bangladesh in 2009 to that in 2013?
Offer a very short reply. 0.47. What is the ratio of the Depositors(per 1000 adults) in Gabon in 2009 to that in 2013?
Your response must be concise. 0.65. What is the ratio of the Depositors(per 1000 adults) in Guinea in 2009 to that in 2013?
Provide a short and direct response. 0.62. What is the ratio of the Depositors(per 1000 adults) in Lower middle income in 2010 to that in 2011?
Your answer should be very brief. 0.8. What is the ratio of the Depositors(per 1000 adults) of Bangladesh in 2010 to that in 2011?
Ensure brevity in your answer.  0.7. What is the ratio of the Depositors(per 1000 adults) in Gabon in 2010 to that in 2011?
Offer a terse response. 0.9. What is the ratio of the Depositors(per 1000 adults) of Guinea in 2010 to that in 2011?
Provide a succinct answer. 0.9. What is the ratio of the Depositors(per 1000 adults) of Lower middle income in 2010 to that in 2012?
Make the answer very short. 0.72. What is the ratio of the Depositors(per 1000 adults) of Bangladesh in 2010 to that in 2012?
Your answer should be compact. 0.61. What is the ratio of the Depositors(per 1000 adults) of Gabon in 2010 to that in 2012?
Ensure brevity in your answer.  0.93. What is the ratio of the Depositors(per 1000 adults) in Guinea in 2010 to that in 2012?
Provide a succinct answer. 0.78. What is the ratio of the Depositors(per 1000 adults) in Lower middle income in 2010 to that in 2013?
Offer a terse response. 0.73. What is the ratio of the Depositors(per 1000 adults) of Bangladesh in 2010 to that in 2013?
Keep it short and to the point. 0.56. What is the ratio of the Depositors(per 1000 adults) in Gabon in 2010 to that in 2013?
Your answer should be compact. 0.73. What is the ratio of the Depositors(per 1000 adults) of Guinea in 2010 to that in 2013?
Provide a succinct answer. 0.72. What is the ratio of the Depositors(per 1000 adults) of Lower middle income in 2011 to that in 2012?
Provide a short and direct response. 0.9. What is the ratio of the Depositors(per 1000 adults) of Bangladesh in 2011 to that in 2012?
Give a very brief answer. 0.87. What is the ratio of the Depositors(per 1000 adults) in Guinea in 2011 to that in 2012?
Make the answer very short. 0.87. What is the ratio of the Depositors(per 1000 adults) of Lower middle income in 2011 to that in 2013?
Ensure brevity in your answer.  0.91. What is the ratio of the Depositors(per 1000 adults) of Bangladesh in 2011 to that in 2013?
Your answer should be compact. 0.81. What is the ratio of the Depositors(per 1000 adults) in Gabon in 2011 to that in 2013?
Provide a succinct answer. 0.81. What is the ratio of the Depositors(per 1000 adults) of Guinea in 2011 to that in 2013?
Provide a succinct answer. 0.8. What is the ratio of the Depositors(per 1000 adults) of Lower middle income in 2012 to that in 2013?
Keep it short and to the point. 1.01. What is the ratio of the Depositors(per 1000 adults) of Bangladesh in 2012 to that in 2013?
Offer a very short reply. 0.92. What is the ratio of the Depositors(per 1000 adults) in Gabon in 2012 to that in 2013?
Offer a terse response. 0.78. What is the ratio of the Depositors(per 1000 adults) in Guinea in 2012 to that in 2013?
Make the answer very short. 0.92. What is the difference between the highest and the second highest Depositors(per 1000 adults) in Lower middle income?
Your response must be concise. 3.82. What is the difference between the highest and the second highest Depositors(per 1000 adults) of Bangladesh?
Offer a terse response. 43.98. What is the difference between the highest and the second highest Depositors(per 1000 adults) in Gabon?
Offer a very short reply. 44.69. What is the difference between the highest and the second highest Depositors(per 1000 adults) in Guinea?
Offer a terse response. 5.09. What is the difference between the highest and the lowest Depositors(per 1000 adults) of Lower middle income?
Ensure brevity in your answer.  180.42. What is the difference between the highest and the lowest Depositors(per 1000 adults) in Bangladesh?
Ensure brevity in your answer.  307.05. What is the difference between the highest and the lowest Depositors(per 1000 adults) of Gabon?
Make the answer very short. 82.52. What is the difference between the highest and the lowest Depositors(per 1000 adults) in Guinea?
Offer a terse response. 29.43. 